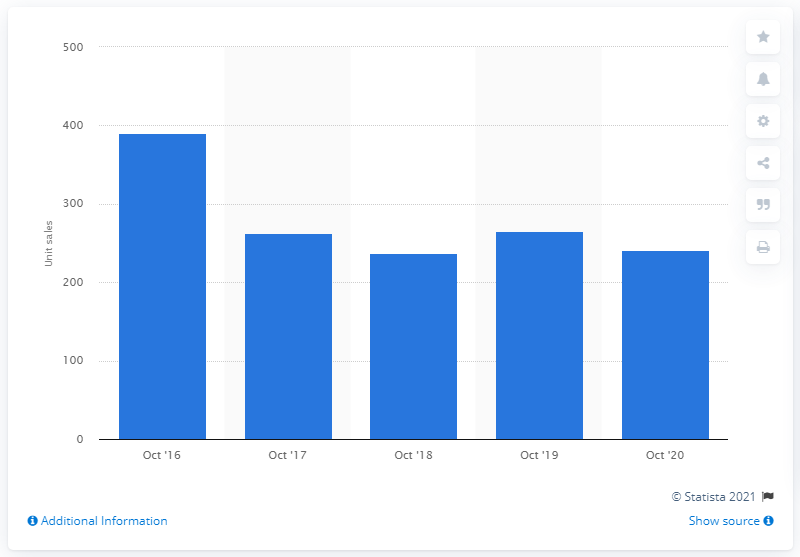Indicate a few pertinent items in this graphic. In October 2020, customers in the UK purchased 241 Piaggio two-wheelers. In October 2020, a total of 237 Piaggio two-wheelers were sold in the UK. 